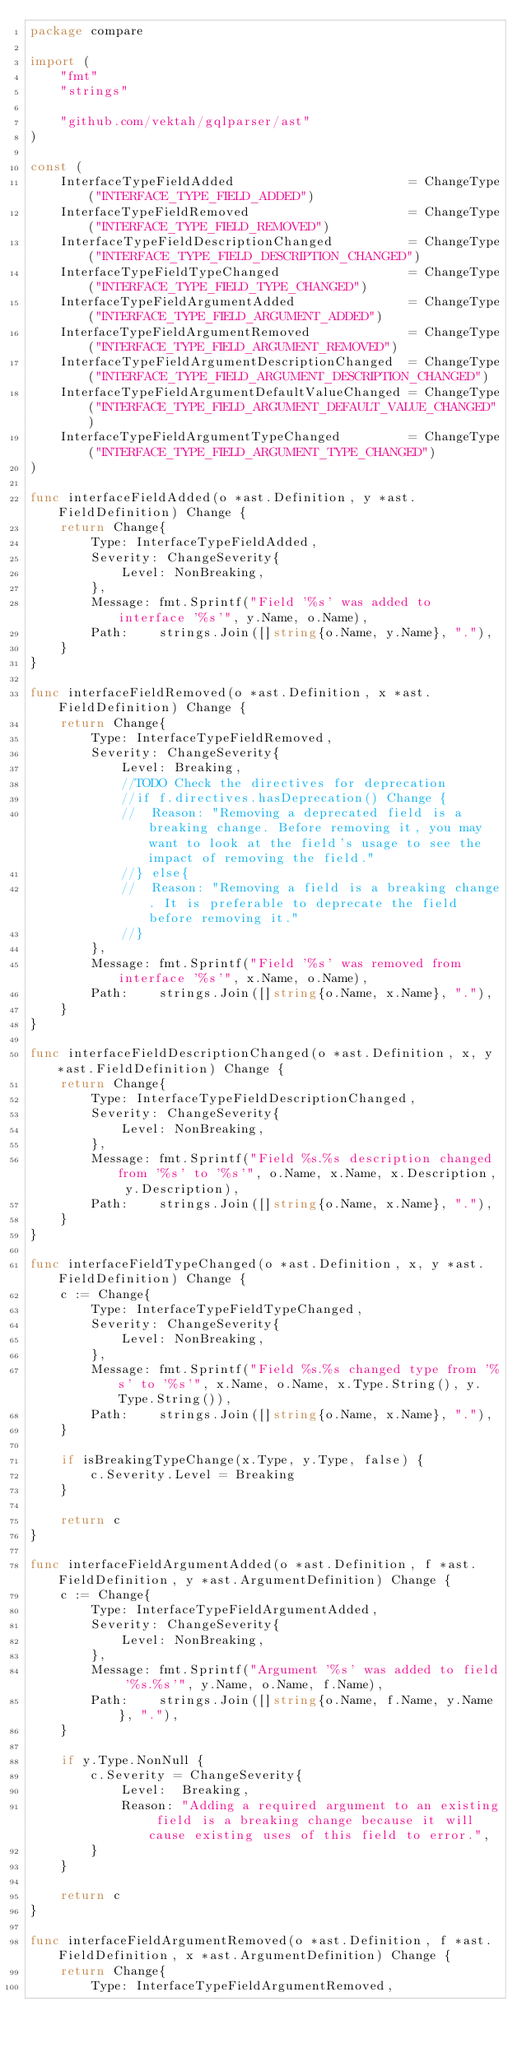Convert code to text. <code><loc_0><loc_0><loc_500><loc_500><_Go_>package compare

import (
	"fmt"
	"strings"

	"github.com/vektah/gqlparser/ast"
)

const (
	InterfaceTypeFieldAdded                       = ChangeType("INTERFACE_TYPE_FIELD_ADDED")
	InterfaceTypeFieldRemoved                     = ChangeType("INTERFACE_TYPE_FIELD_REMOVED")
	InterfaceTypeFieldDescriptionChanged          = ChangeType("INTERFACE_TYPE_FIELD_DESCRIPTION_CHANGED")
	InterfaceTypeFieldTypeChanged                 = ChangeType("INTERFACE_TYPE_FIELD_TYPE_CHANGED")
	InterfaceTypeFieldArgumentAdded               = ChangeType("INTERFACE_TYPE_FIELD_ARGUMENT_ADDED")
	InterfaceTypeFieldArgumentRemoved             = ChangeType("INTERFACE_TYPE_FIELD_ARGUMENT_REMOVED")
	InterfaceTypeFieldArgumentDescriptionChanged  = ChangeType("INTERFACE_TYPE_FIELD_ARGUMENT_DESCRIPTION_CHANGED")
	InterfaceTypeFieldArgumentDefaultValueChanged = ChangeType("INTERFACE_TYPE_FIELD_ARGUMENT_DEFAULT_VALUE_CHANGED")
	InterfaceTypeFieldArgumentTypeChanged         = ChangeType("INTERFACE_TYPE_FIELD_ARGUMENT_TYPE_CHANGED")
)

func interfaceFieldAdded(o *ast.Definition, y *ast.FieldDefinition) Change {
	return Change{
		Type: InterfaceTypeFieldAdded,
		Severity: ChangeSeverity{
			Level: NonBreaking,
		},
		Message: fmt.Sprintf("Field '%s' was added to interface '%s'", y.Name, o.Name),
		Path:    strings.Join([]string{o.Name, y.Name}, "."),
	}
}

func interfaceFieldRemoved(o *ast.Definition, x *ast.FieldDefinition) Change {
	return Change{
		Type: InterfaceTypeFieldRemoved,
		Severity: ChangeSeverity{
			Level: Breaking,
			//TODO Check the directives for deprecation
			//if f.directives.hasDeprecation() Change {
			//	Reason: "Removing a deprecated field is a breaking change. Before removing it, you may want to look at the field's usage to see the impact of removing the field."
			//} else{
			//	Reason: "Removing a field is a breaking change. It is preferable to deprecate the field before removing it."
			//}
		},
		Message: fmt.Sprintf("Field '%s' was removed from interface '%s'", x.Name, o.Name),
		Path:    strings.Join([]string{o.Name, x.Name}, "."),
	}
}

func interfaceFieldDescriptionChanged(o *ast.Definition, x, y *ast.FieldDefinition) Change {
	return Change{
		Type: InterfaceTypeFieldDescriptionChanged,
		Severity: ChangeSeverity{
			Level: NonBreaking,
		},
		Message: fmt.Sprintf("Field %s.%s description changed from '%s' to '%s'", o.Name, x.Name, x.Description, y.Description),
		Path:    strings.Join([]string{o.Name, x.Name}, "."),
	}
}

func interfaceFieldTypeChanged(o *ast.Definition, x, y *ast.FieldDefinition) Change {
	c := Change{
		Type: InterfaceTypeFieldTypeChanged,
		Severity: ChangeSeverity{
			Level: NonBreaking,
		},
		Message: fmt.Sprintf("Field %s.%s changed type from '%s' to '%s'", x.Name, o.Name, x.Type.String(), y.Type.String()),
		Path:    strings.Join([]string{o.Name, x.Name}, "."),
	}

	if isBreakingTypeChange(x.Type, y.Type, false) {
		c.Severity.Level = Breaking
	}

	return c
}

func interfaceFieldArgumentAdded(o *ast.Definition, f *ast.FieldDefinition, y *ast.ArgumentDefinition) Change {
	c := Change{
		Type: InterfaceTypeFieldArgumentAdded,
		Severity: ChangeSeverity{
			Level: NonBreaking,
		},
		Message: fmt.Sprintf("Argument '%s' was added to field '%s.%s'", y.Name, o.Name, f.Name),
		Path:    strings.Join([]string{o.Name, f.Name, y.Name}, "."),
	}

	if y.Type.NonNull {
		c.Severity = ChangeSeverity{
			Level:  Breaking,
			Reason: "Adding a required argument to an existing field is a breaking change because it will cause existing uses of this field to error.",
		}
	}

	return c
}

func interfaceFieldArgumentRemoved(o *ast.Definition, f *ast.FieldDefinition, x *ast.ArgumentDefinition) Change {
	return Change{
		Type: InterfaceTypeFieldArgumentRemoved,</code> 